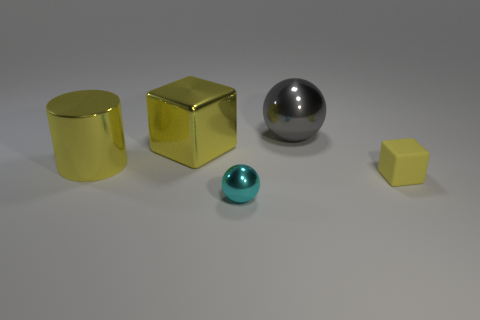Add 1 big gray shiny objects. How many objects exist? 6 Subtract all cubes. How many objects are left? 3 Subtract all tiny yellow rubber blocks. Subtract all cylinders. How many objects are left? 3 Add 3 yellow shiny cubes. How many yellow shiny cubes are left? 4 Add 1 small matte cubes. How many small matte cubes exist? 2 Subtract 0 gray cubes. How many objects are left? 5 